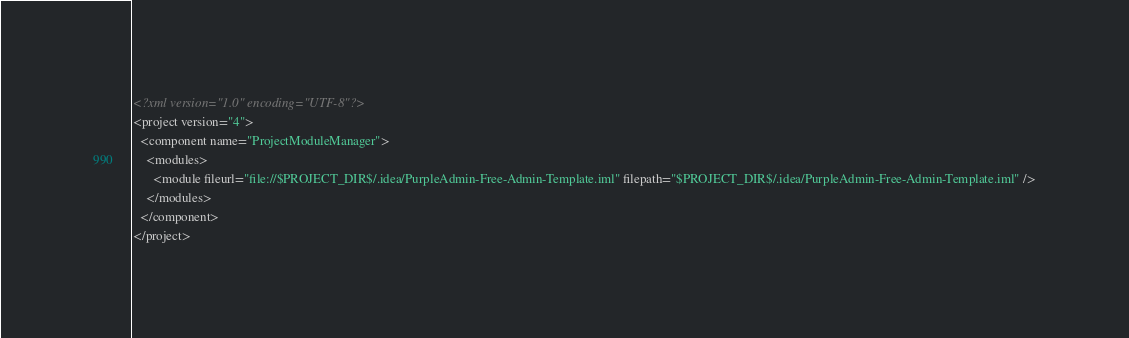Convert code to text. <code><loc_0><loc_0><loc_500><loc_500><_XML_><?xml version="1.0" encoding="UTF-8"?>
<project version="4">
  <component name="ProjectModuleManager">
    <modules>
      <module fileurl="file://$PROJECT_DIR$/.idea/PurpleAdmin-Free-Admin-Template.iml" filepath="$PROJECT_DIR$/.idea/PurpleAdmin-Free-Admin-Template.iml" />
    </modules>
  </component>
</project></code> 